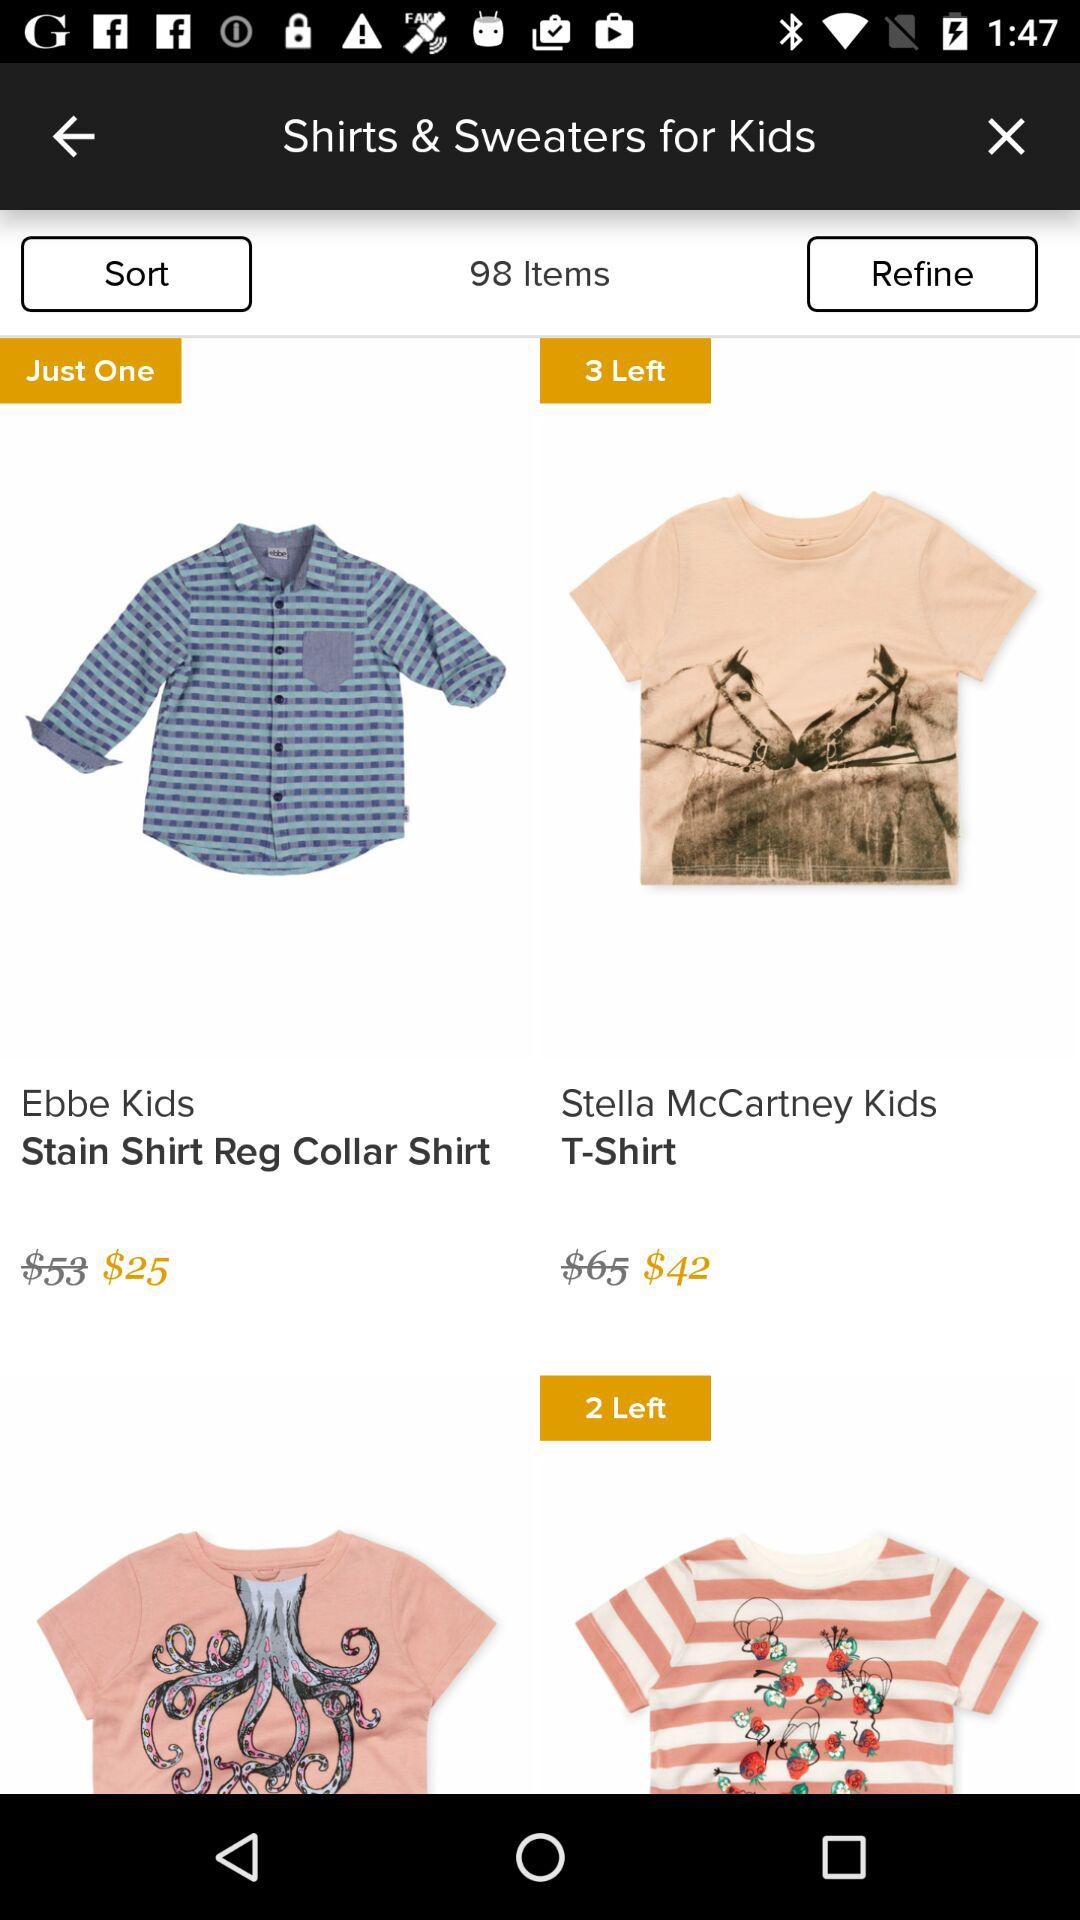What is the price of the Ebbe Kids' stain shirt regular collar shirt? The price is $25. 